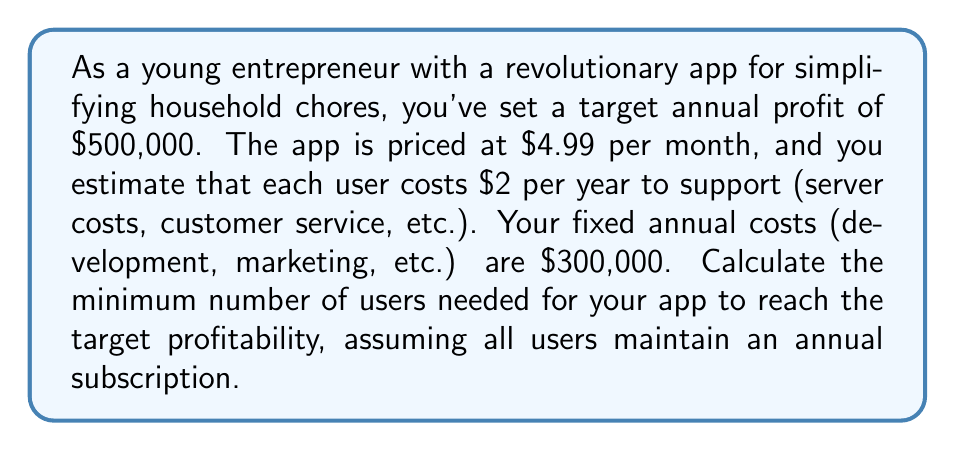Could you help me with this problem? Let's approach this step-by-step:

1) First, let's define our variables:
   $x$ = number of users
   $P$ = annual profit

2) We can express the annual profit as:
   $P = \text{Annual Revenue} - \text{Annual Costs}$

3) Annual Revenue:
   Monthly price per user: $4.99
   Annual price per user: $4.99 \times 12 = $59.88
   Total annual revenue: $59.88x$

4) Annual Costs:
   Fixed costs: $300,000
   Variable costs per user: $2x
   Total annual costs: $300,000 + 2x$

5) Now we can set up our profit equation:
   $P = 59.88x - (300,000 + 2x)$
   $P = 59.88x - 300,000 - 2x$
   $P = 57.88x - 300,000$

6) We want to find the minimum number of users for $P = 500,000$:
   $500,000 = 57.88x - 300,000$
   $800,000 = 57.88x$

7) Solving for $x$:
   $x = \frac{800,000}{57.88} \approx 13,821.35$

8) Since we can't have a fractional number of users, we need to round up to the nearest whole number.
Answer: The minimum number of users needed for profitability is 13,822. 